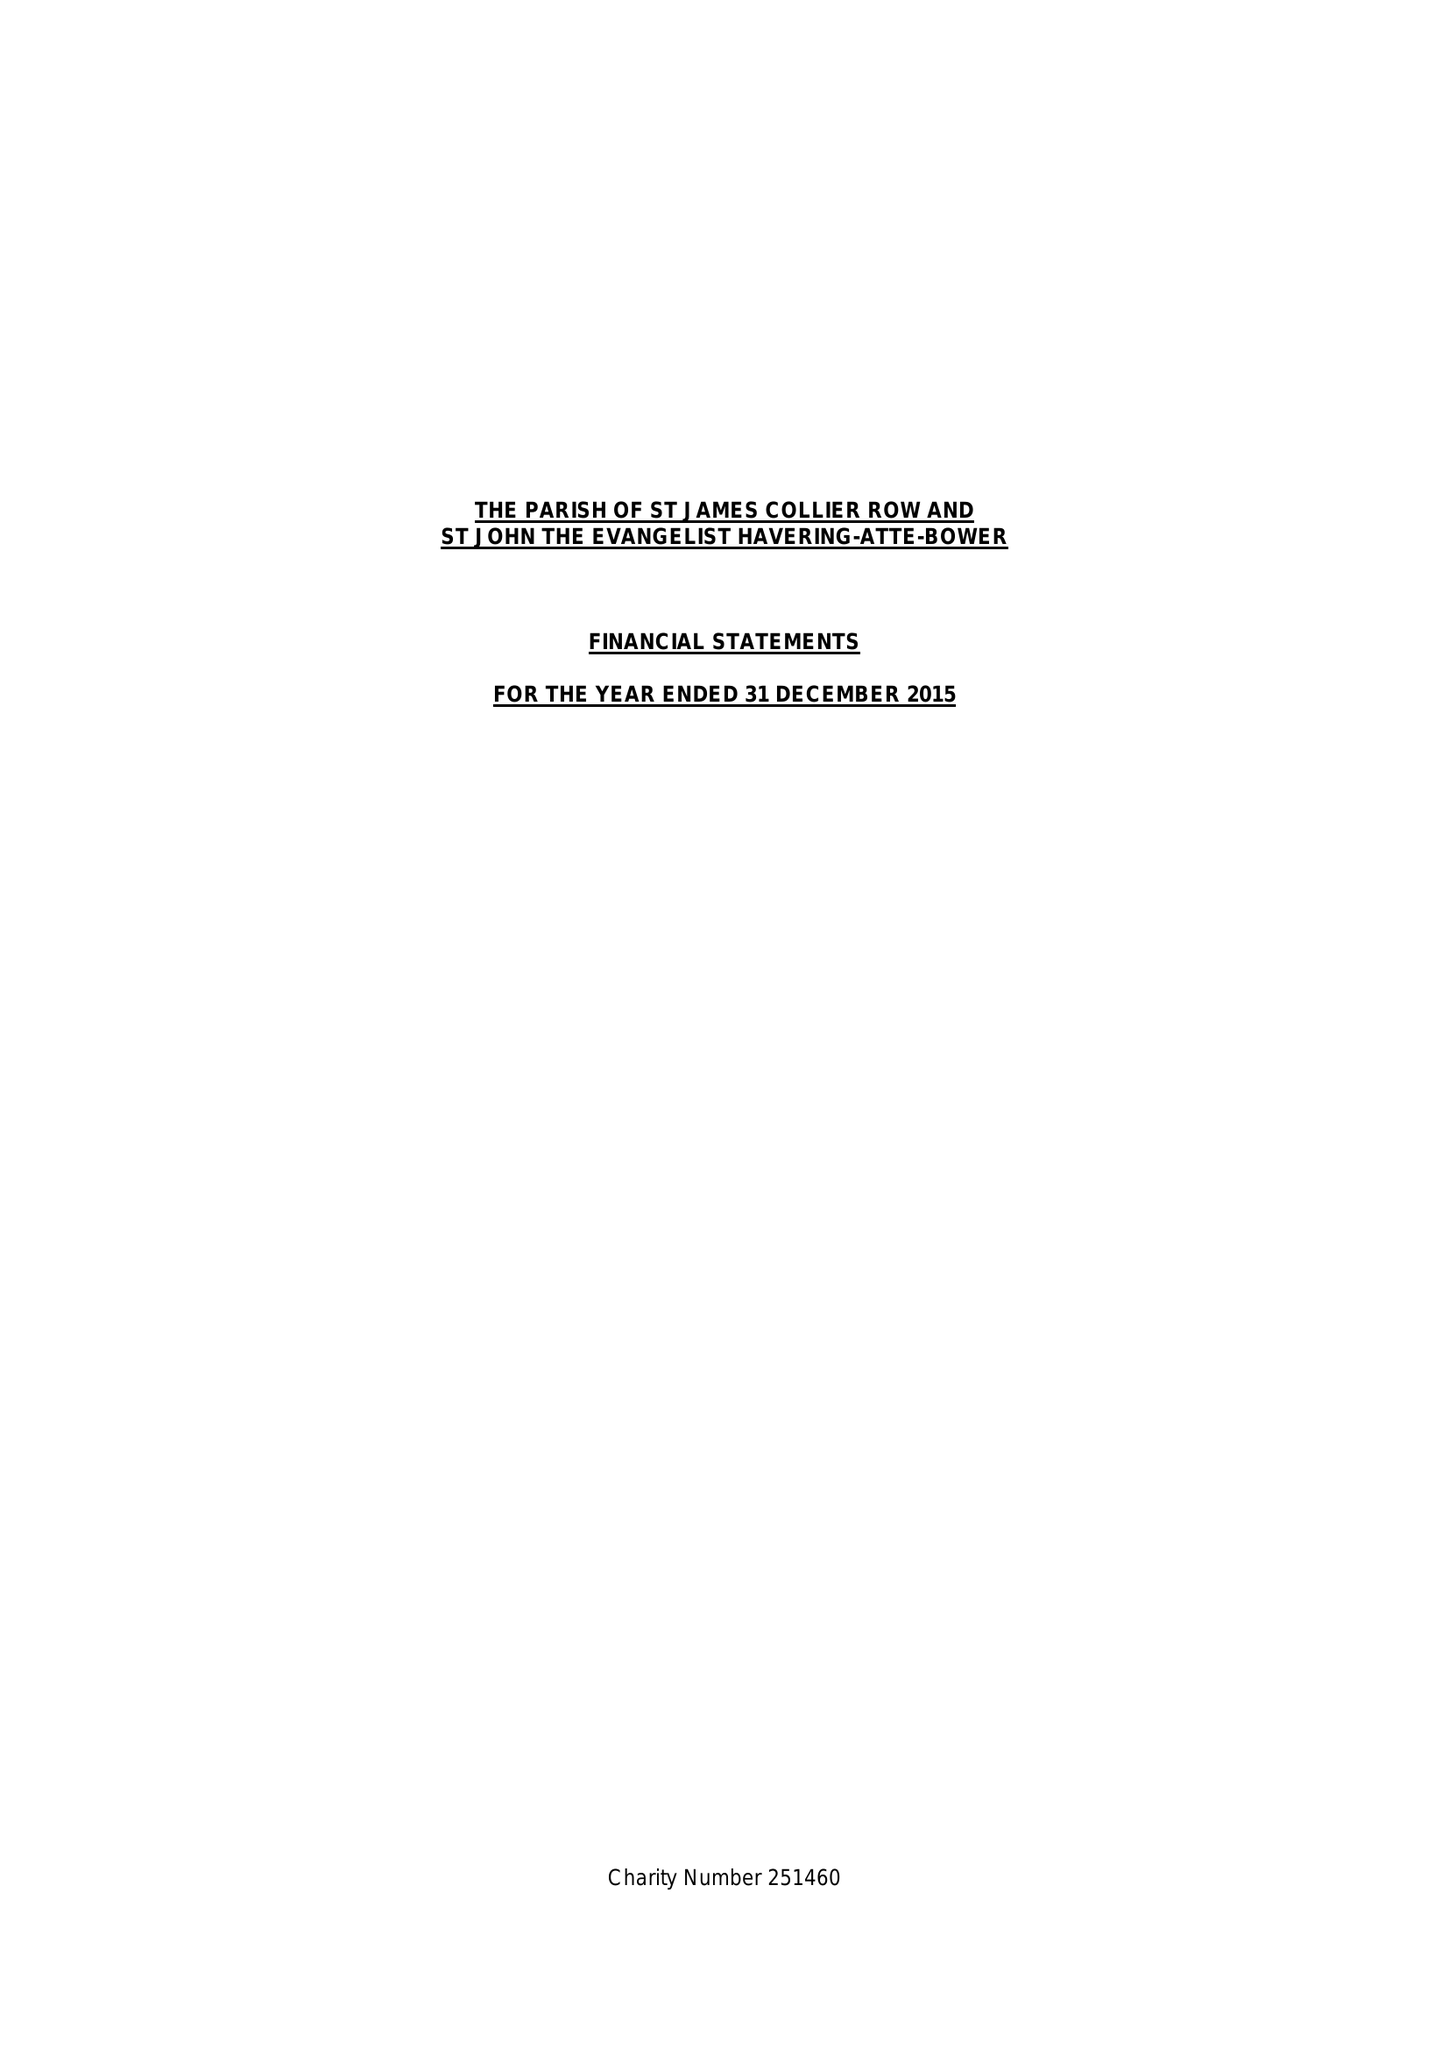What is the value for the charity_name?
Answer the question using a single word or phrase. The Parish Of Saint James Collier Row and Saint John Havering-Atte-Bower 